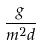Convert formula to latex. <formula><loc_0><loc_0><loc_500><loc_500>\frac { g } { m ^ { 2 } d }</formula> 